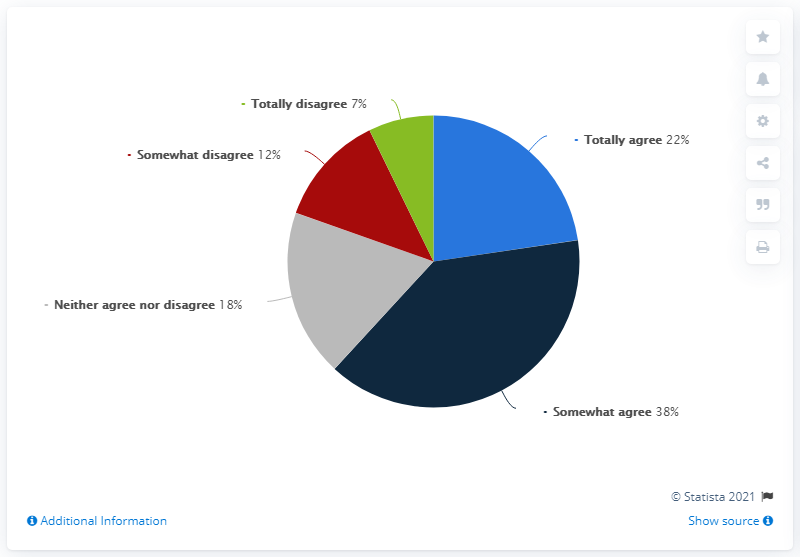WHat is the average of totally agree and somewhat agree?
 60 